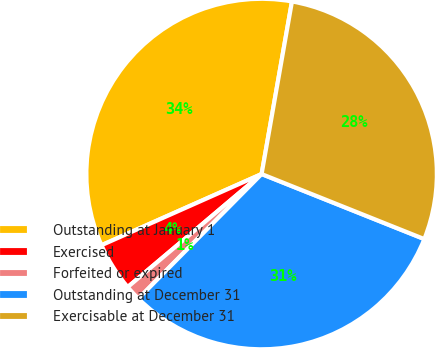Convert chart to OTSL. <chart><loc_0><loc_0><loc_500><loc_500><pie_chart><fcel>Outstanding at January 1<fcel>Exercised<fcel>Forfeited or expired<fcel>Outstanding at December 31<fcel>Exercisable at December 31<nl><fcel>34.43%<fcel>4.5%<fcel>1.43%<fcel>31.36%<fcel>28.28%<nl></chart> 